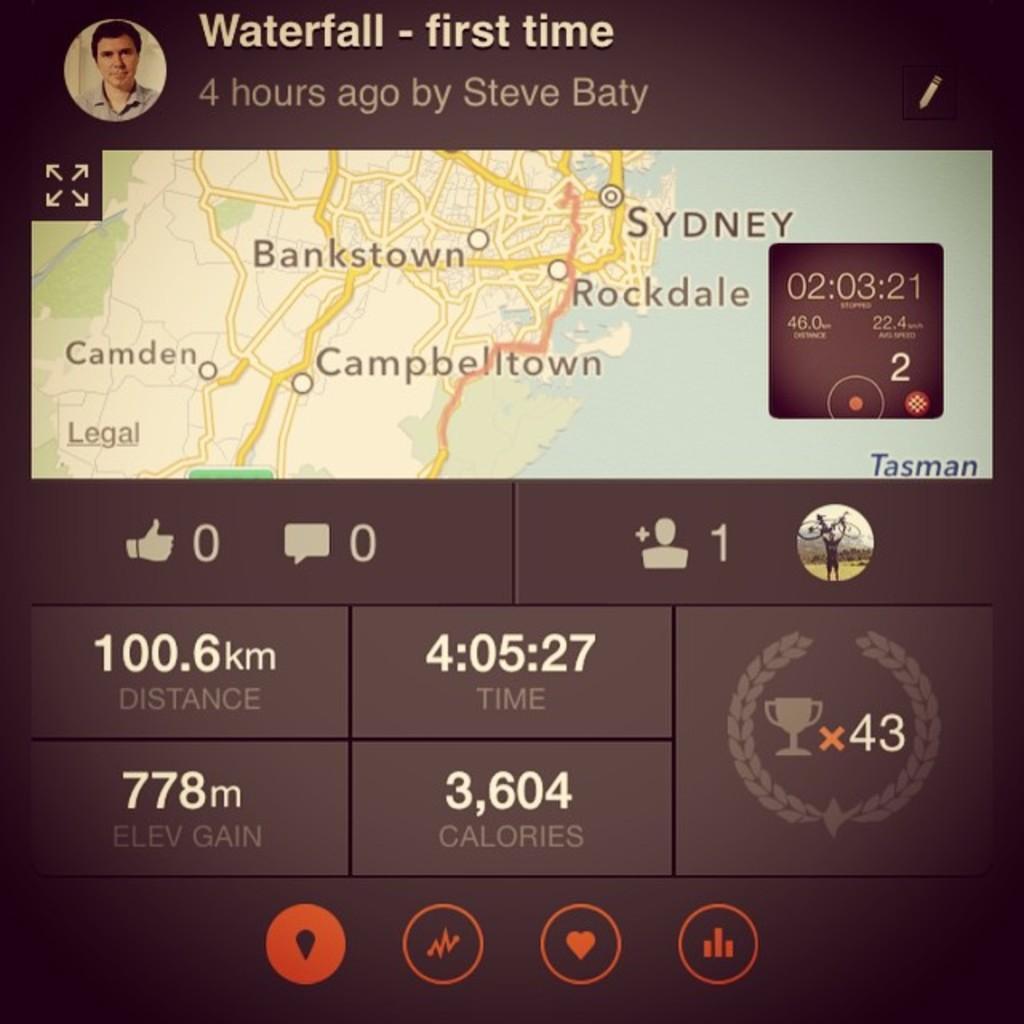Describe this image in one or two sentences. In the foreground I can see a route map, timer, icons. On the top I can see a person and text. This image is taken may be from the screen. 